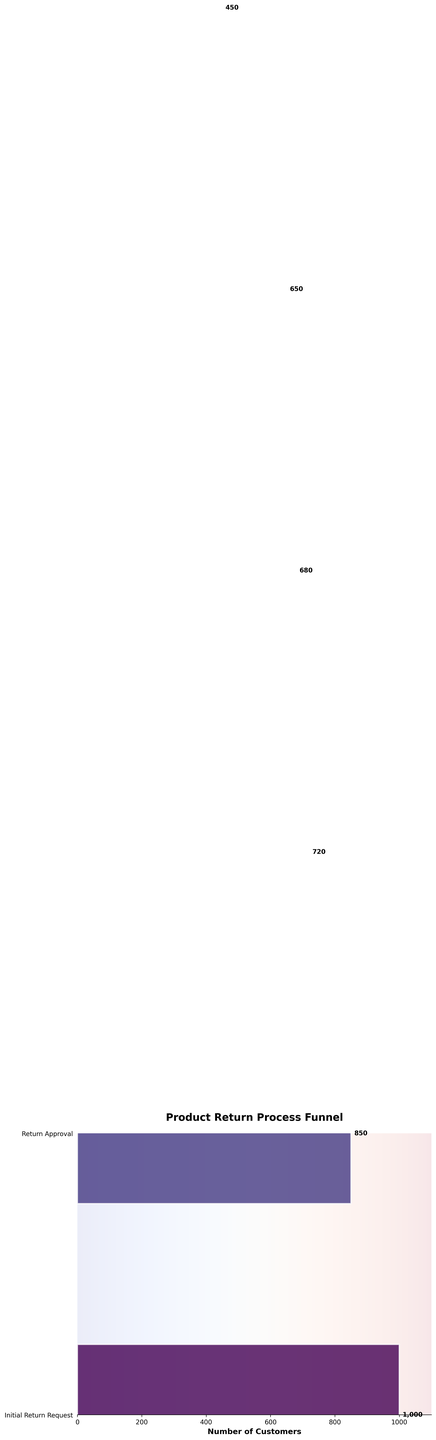What is the title of the chart? The title can be found at the top of the chart, which is bolded and set in a larger font size.
Answer: Product Return Process Funnel How many customers reached the 'Return Shipping' stage? The number next to the 'Return Shipping' stage bar indicates the number of customers at this stage.
Answer: 720 What is the last stage in the product return process shown in the funnel chart? The funnel chart displays the stages sequentially from top to bottom. The last stage is at the bottom.
Answer: Customer Feedback How many more customers made the Initial Return Request compared to those who provided Customer Feedback? Subtract the number of customers at the 'Customer Feedback' stage from those at the 'Initial Return Request' stage. 1000 - 450 = 550
Answer: 550 What is the attrition rate between the 'Return Approval' and 'Return Shipping' stages? Determine the number of customers who did not proceed from 'Return Approval' to 'Return Shipping' by subtracting the latter from the former, then divide by the 'Return Approval' number and multiply by 100. (850 - 720) / 850 * 100 = 15.29%
Answer: 15.29% Which stage experienced the highest attrition rate, and what is it? Compare the differences in customers between each consecutive stage, then divide by the number from the earlier stage, multiplying by 100. The biggest rate differences indicate the highest attrition. For instance, (650 - 450) / 650 * 100 ≈ 30.77%, which is the highest between 'Refund Processed' and 'Customer Feedback'.
Answer: Customer Feedback; 30.77% How many customers dropped off between 'Initial Return Request' and 'Item Received'? Subtract the number of customers at the 'Item Received' stage from the number at the 'Initial Return Request' stage. 1000 - 680 = 320
Answer: 320 Which stage has the narrowest bar width, and what does this signify? The chart shows varying widths for each stage bar. The narrowest bar width signifies the stage with the fewest remaining customers: 'Customer Feedback'.
Answer: Customer Feedback; signifies the fewest customers Is the number of customers who completed 'Return Approval' higher or lower than those who completed 'Refund Processed'? Compare the number of customers at the 'Return Approval' stage to those at the 'Refund Processed' stage. 850 vs. 650, indicating 'Return Approval' is higher.
Answer: Higher What percentage of customers who initiated a return actually receive a refund? Divide the number of customers at the 'Refund Processed' stage by those at the 'Initial Return Request' stage, then multiply by 100. 650 / 1000 * 100 = 65%
Answer: 65% 